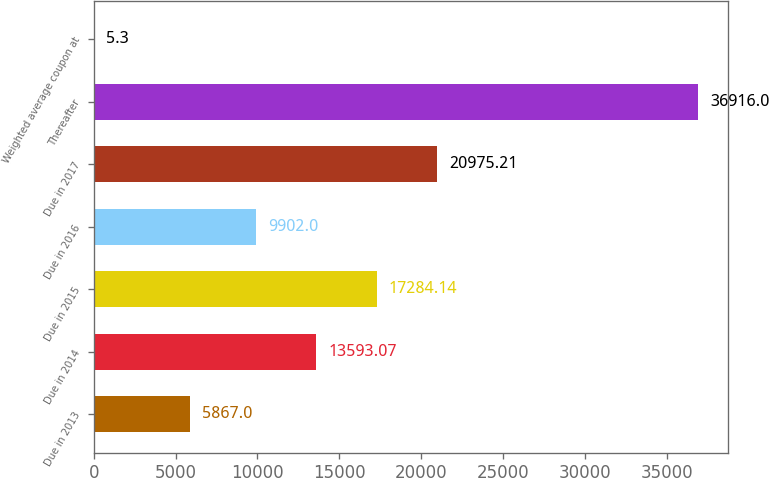<chart> <loc_0><loc_0><loc_500><loc_500><bar_chart><fcel>Due in 2013<fcel>Due in 2014<fcel>Due in 2015<fcel>Due in 2016<fcel>Due in 2017<fcel>Thereafter<fcel>Weighted average coupon at<nl><fcel>5867<fcel>13593.1<fcel>17284.1<fcel>9902<fcel>20975.2<fcel>36916<fcel>5.3<nl></chart> 